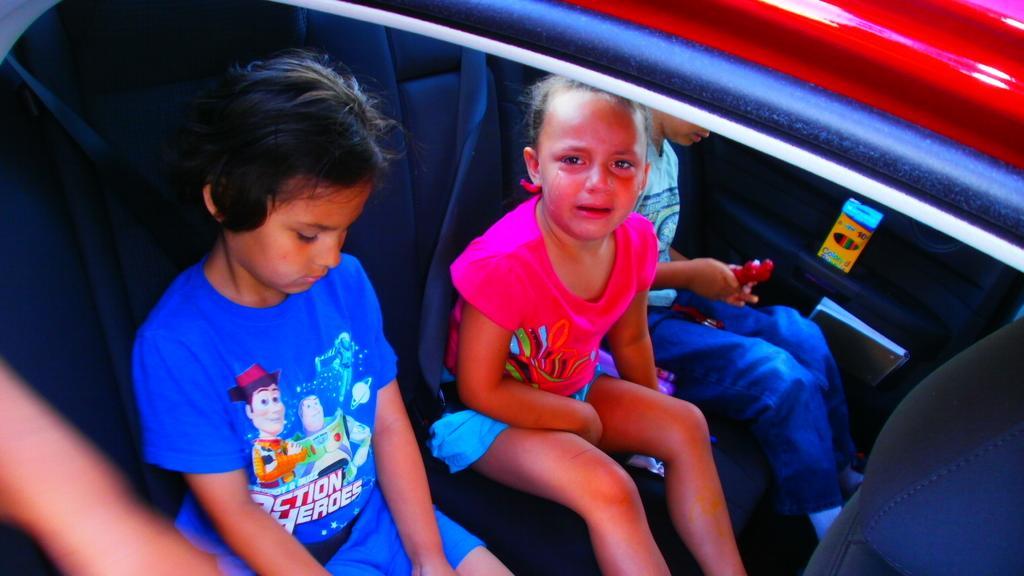Describe this image in one or two sentences. There are three kids sat in the car, The first kid was wearing a blue having action heroes on it is seeing downwards and the other kid who is wearing pink dress is crying and the third kid who is wearing light blue dress is playing with a toy and there are also sketch pens and a book on the right side and the color of the car is red. 